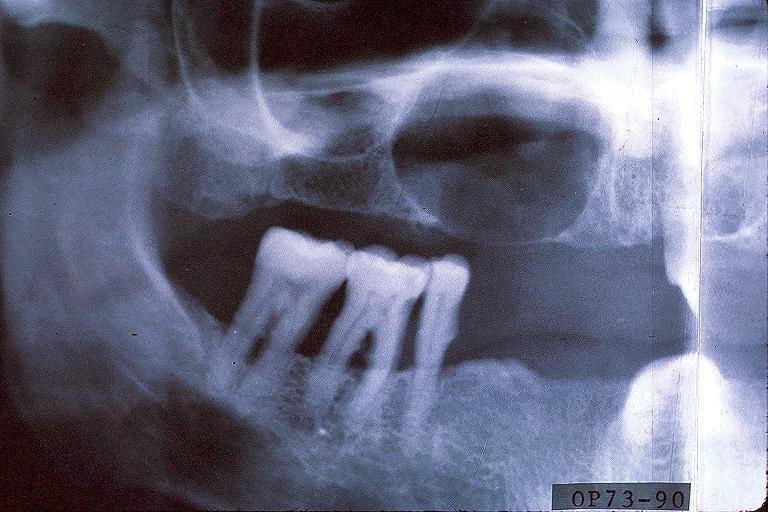does stress show cyst?
Answer the question using a single word or phrase. No 